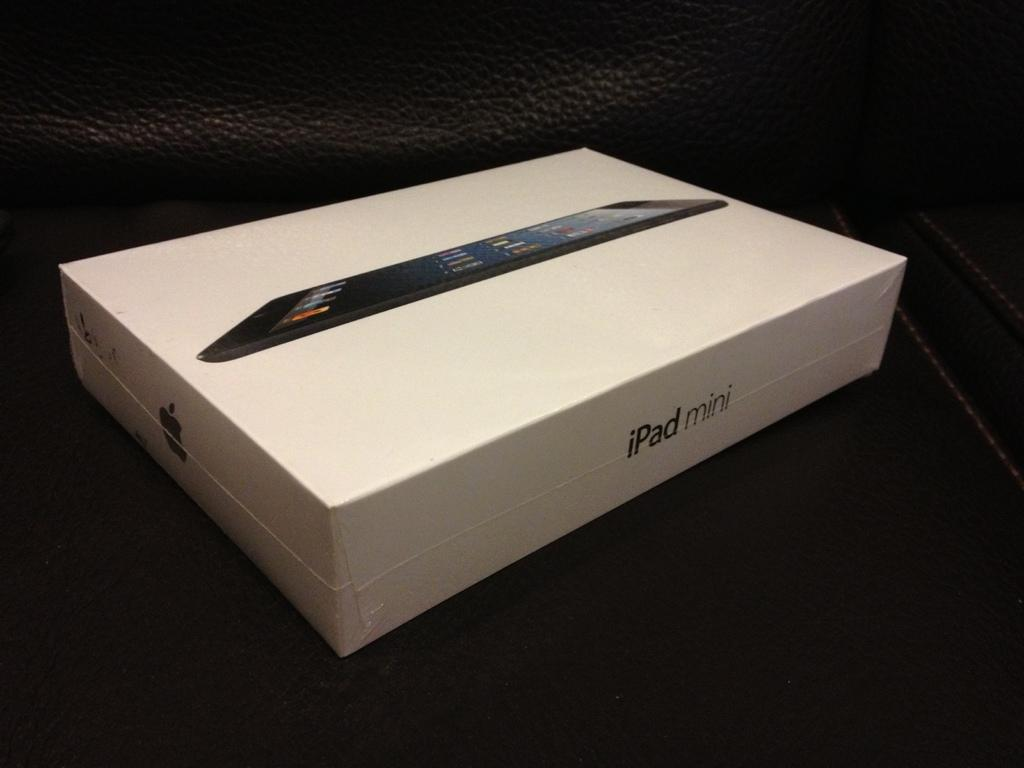<image>
Give a short and clear explanation of the subsequent image. A white box with a ipad mini on the cover and an apple logo on the side. 